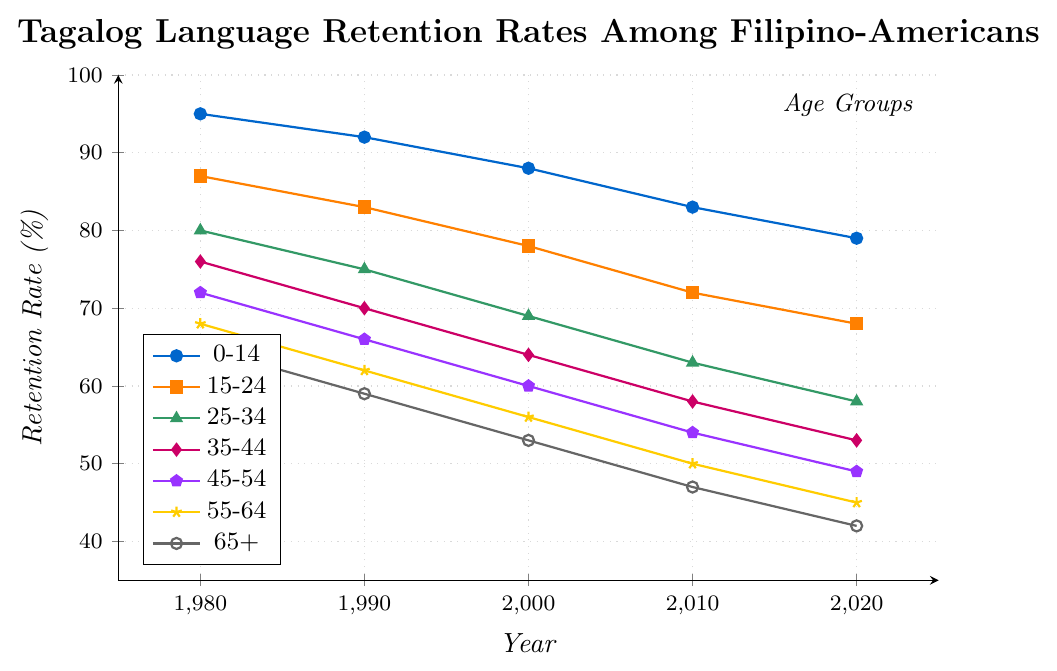Which age group had the highest retention rate in 1980? The age group 0-14 had a retention rate of 95% in 1980, which is the highest among all age groups.
Answer: 0-14 Which age group had the lowest retention rate in 2020? The age group 65+ had the lowest retention rate of 42% in 2020.
Answer: 65+ What is the average retention rate of the 35-44 age group over the years provided? The retention rates for the 35-44 age group are 76%, 70%, 64%, 58%, and 53%. Adding these together gives 321%, and dividing by 5 gives an average of 64.2%.
Answer: 64.2% How does the retention rate of the 25-34 age group in 1990 compare to that in 2020? In 1990, the retention rate for the 25-34 age group was 75%, and in 2020 it was 58%. The rate in 2020 is 17% lower.
Answer: 17% lower Between which years did the 0-14 age group's retention rate drop the most significantly? The retention rate for the 0-14 age group dropped from 88% to 83% between 2000 and 2010, which is the largest drop of 5%.
Answer: 2000 to 2010 What is the overall trend in the retention rates of the 55-64 age group from 1980 to 2020? The retention rates consistently decrease from 68% in 1980 to 45% in 2020 for the 55-64 age group, indicating a downward trend.
Answer: Downward trend Among the age groups, who experienced the most considerable decline in retention rate from 1980 to 2020? The 35-44 age group experienced a decline from 76% in 1980 to 53% in 2020, a total decline of 23%, which is the most considerable decline among all age groups.
Answer: 35-44 Which two age groups have retention rates closest to each other in 2010? In 2010, the retention rates for the 45-54 and 55-64 age groups are 54% and 50%, respectively, making them the closest.
Answer: 45-54 and 55-64 What is the median retention rate for all age groups in 2020? The retention rates in 2020 across all age groups are 79%, 68%, 58%, 53%, 49%, 45%, and 42%. Ordering these values gives 42%, 45%, 49%, 53%, 58%, 68%, 79%, with the median being 53%.
Answer: 53% How does the overall trend in retention rates from 1980 to 2020 compare between the age groups 0-14 and 65+? Both age groups show a downward trend; however, the decline over the years is more substantial in the 0-14 group (16% decrease), compared to the 65+ group (23% decrease).
Answer: Both show a downward trend, 0-14 declines more 